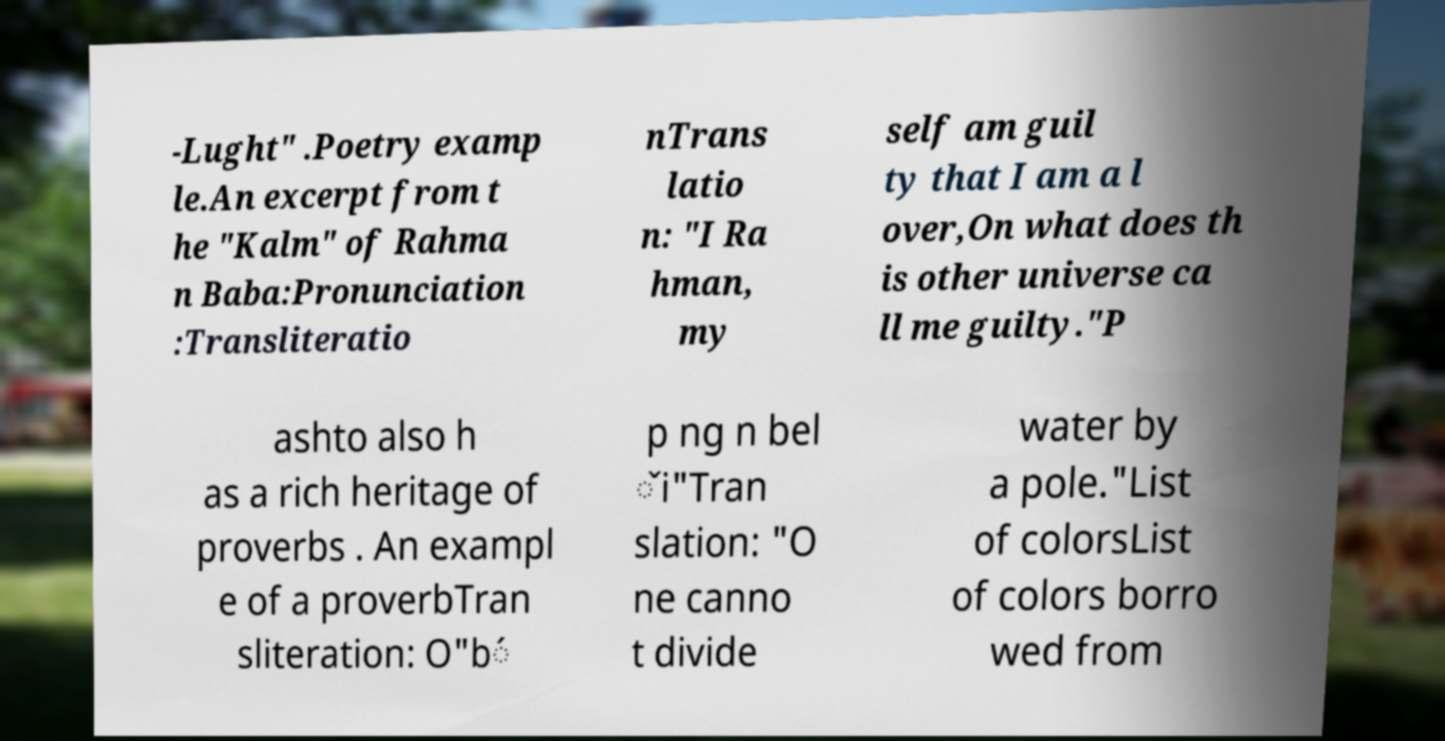Could you assist in decoding the text presented in this image and type it out clearly? -Lught" .Poetry examp le.An excerpt from t he "Kalm" of Rahma n Baba:Pronunciation :Transliteratio nTrans latio n: "I Ra hman, my self am guil ty that I am a l over,On what does th is other universe ca ll me guilty."P ashto also h as a rich heritage of proverbs . An exampl e of a proverbTran sliteration: O"b́ p ng n bel ̌i"Tran slation: "O ne canno t divide water by a pole."List of colorsList of colors borro wed from 